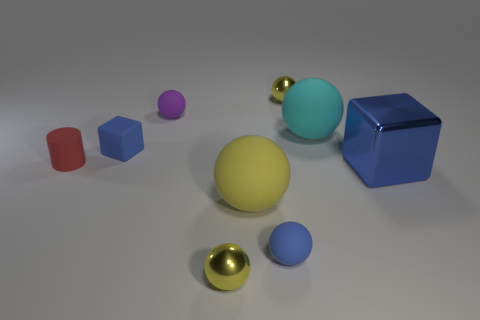Subtract all yellow spheres. How many were subtracted if there are1yellow spheres left? 2 Subtract all purple cylinders. How many yellow balls are left? 3 Subtract all shiny spheres. How many spheres are left? 4 Subtract 3 spheres. How many spheres are left? 3 Add 1 big blue blocks. How many objects exist? 10 Subtract all yellow spheres. How many spheres are left? 3 Subtract all cylinders. How many objects are left? 8 Add 2 cyan rubber objects. How many cyan rubber objects exist? 3 Subtract 2 yellow spheres. How many objects are left? 7 Subtract all gray balls. Subtract all gray blocks. How many balls are left? 6 